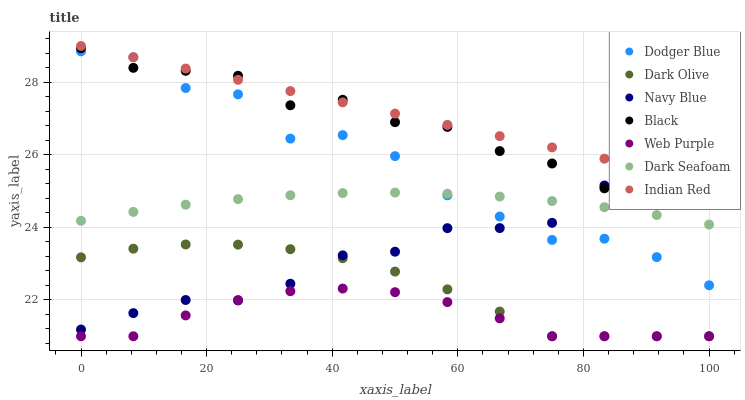Does Web Purple have the minimum area under the curve?
Answer yes or no. Yes. Does Indian Red have the maximum area under the curve?
Answer yes or no. Yes. Does Dark Olive have the minimum area under the curve?
Answer yes or no. No. Does Dark Olive have the maximum area under the curve?
Answer yes or no. No. Is Indian Red the smoothest?
Answer yes or no. Yes. Is Dodger Blue the roughest?
Answer yes or no. Yes. Is Dark Olive the smoothest?
Answer yes or no. No. Is Dark Olive the roughest?
Answer yes or no. No. Does Dark Olive have the lowest value?
Answer yes or no. Yes. Does Dark Seafoam have the lowest value?
Answer yes or no. No. Does Indian Red have the highest value?
Answer yes or no. Yes. Does Dark Olive have the highest value?
Answer yes or no. No. Is Dark Olive less than Dodger Blue?
Answer yes or no. Yes. Is Dodger Blue greater than Dark Olive?
Answer yes or no. Yes. Does Navy Blue intersect Web Purple?
Answer yes or no. Yes. Is Navy Blue less than Web Purple?
Answer yes or no. No. Is Navy Blue greater than Web Purple?
Answer yes or no. No. Does Dark Olive intersect Dodger Blue?
Answer yes or no. No. 